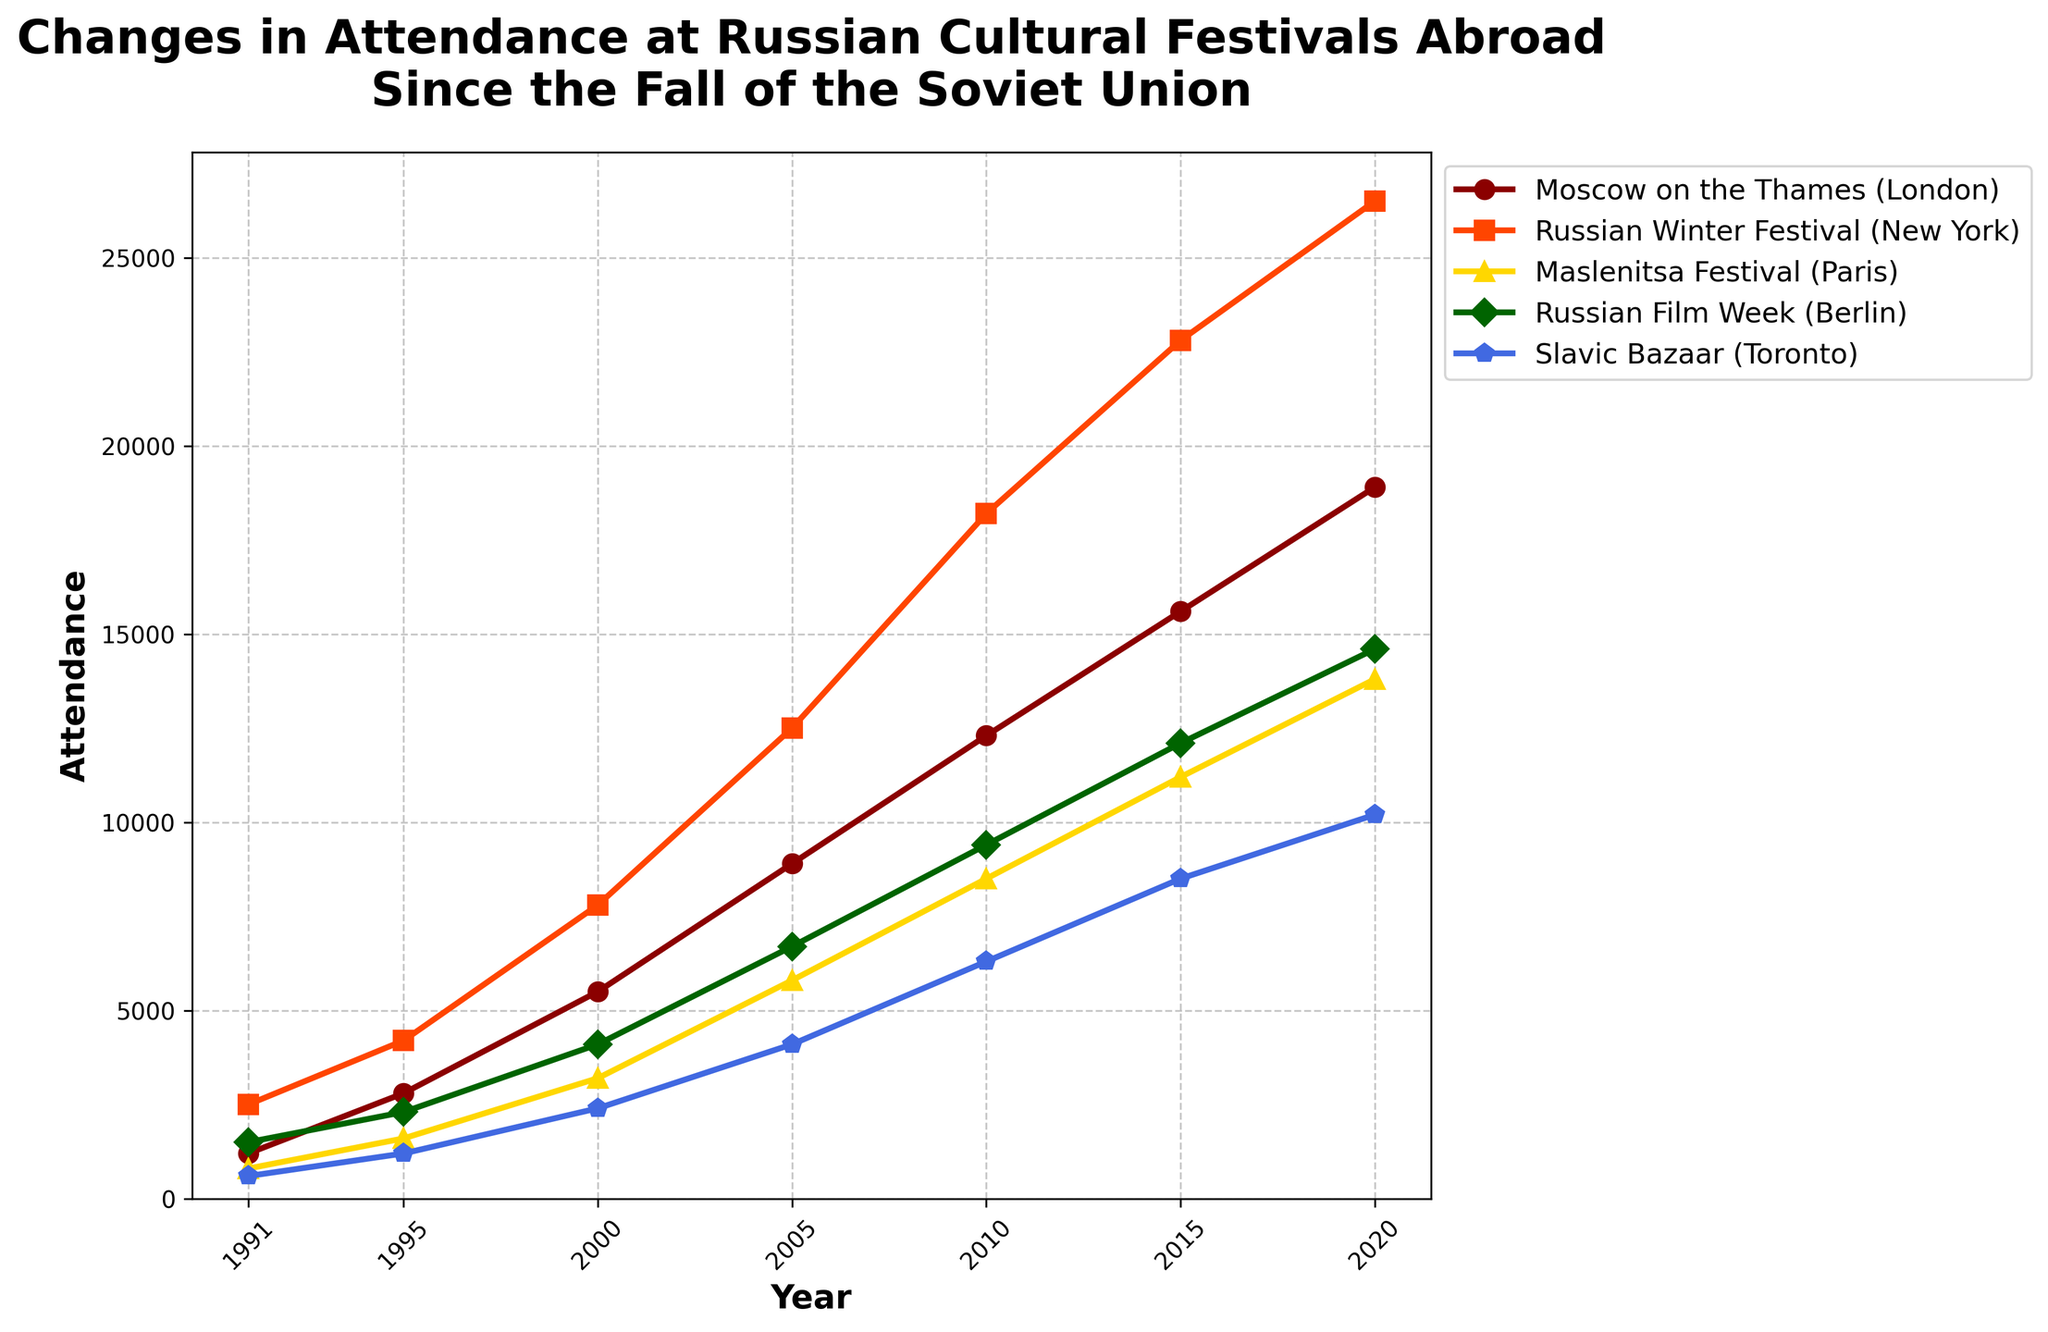Which festival had the highest attendance in 2020? Look at the attendance figures for each festival in 2020. Identify the highest number. The Russian Winter Festival in New York had 26,500 attendees in 2020, making it the highest.
Answer: Russian Winter Festival (New York) Which festival saw the largest increase in attendance from 1991 to 2020? Calculate the difference in attendance for each festival between 1991 and 2020. The Russian Winter Festival in New York increased from 2,500 to 26,500, a total increase of 24,000, which is the largest.
Answer: Russian Winter Festival (New York) How did the attendance of the Moscow on the Thames festival in 2005 compare to the Maslenitsa Festival in the same year? Refer to the attendance figures for both festivals in 2005. Moscow on the Thames had 8,900 attendees, while Maslenitsa Festival had 5,800, so Moscow on the Thames had higher attendance.
Answer: Moscow on the Thames (London) What's the average attendance for the Slavic Bazaar in Toronto from 1991 to 2020? Calculate by summing up the attendance numbers for each year for the Slavic Bazaar and then dividing by the total number of years (7). (600 + 1200 + 2400 + 4100 + 6300 + 8500 + 10200) / 7 = 6,043
Answer: 6,043 Which festival had its attendance double the fastest? Identify the year each festival’s attendance first doubled its 1991 figure, then find the festival where this happened first. Moscow on the Thames doubled its initial attendance by 1995, increasing from 1,200 to 2,800.
Answer: Moscow on the Thames (London) What is the trend in attendance for the Russian Film Week in Berlin from 1991 to 2020? Observe the attendance figures over the years for Russian Film Week. There is a consistent upward trend from 1,500 in 1991 to 14,600 in 2020.
Answer: Increasing Which festival had the smallest increase in attendance from 2015 to 2020? Calculate the difference in attendance for each festival between 2015 and 2020. Compare these differences to find the smallest increase. The Slavic Bazaar increased from 8,500 to 10,200, an increase of 1,700, which is the smallest.
Answer: Slavic Bazaar (Toronto) What is the overall change in attendance for the Russian Winter Festival (New York) from 1991 to 2020? Subtract the 1991 attendance from the 2020 attendance for the Russian Winter Festival. 26,500 - 2,500 = 24,000
Answer: 24,000 